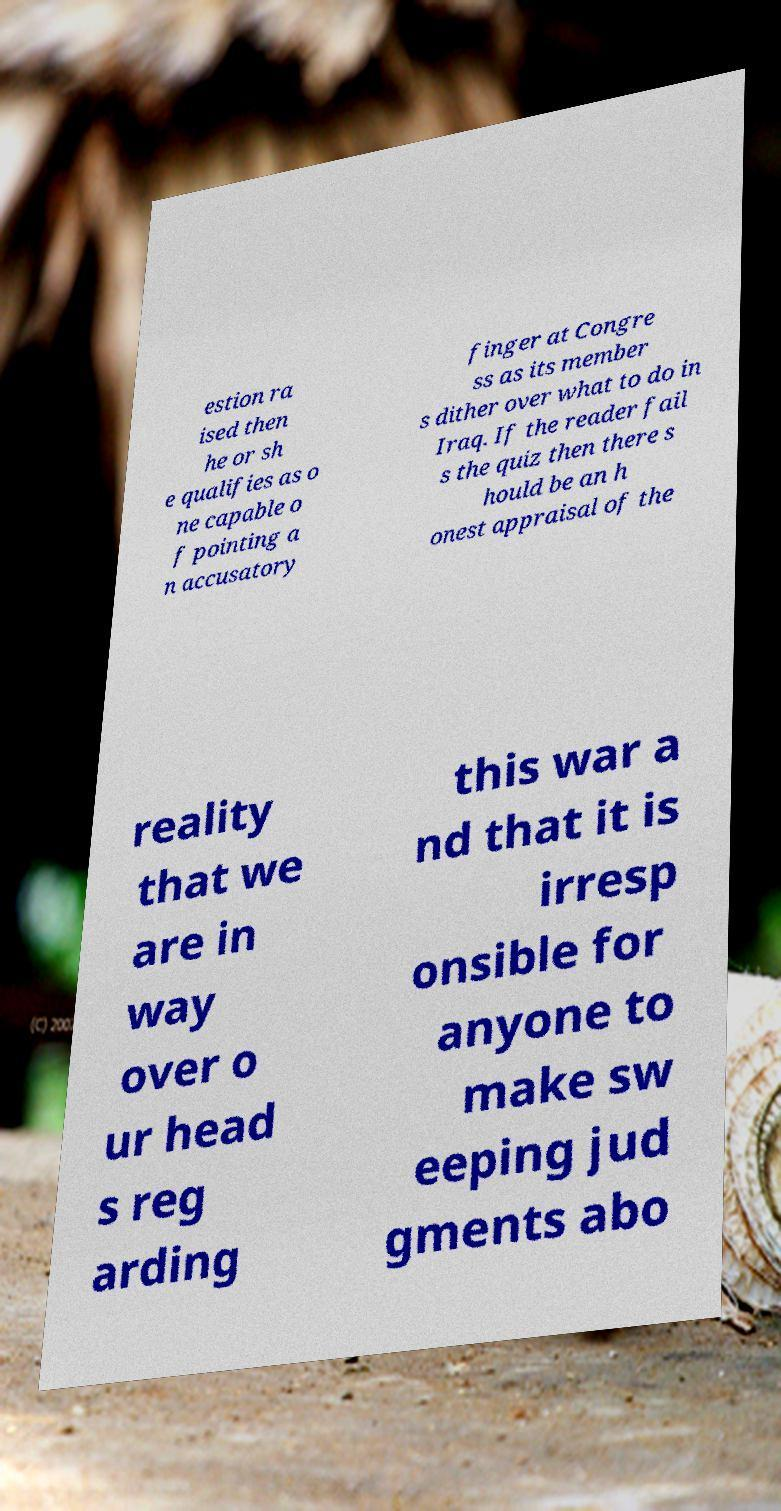Could you assist in decoding the text presented in this image and type it out clearly? estion ra ised then he or sh e qualifies as o ne capable o f pointing a n accusatory finger at Congre ss as its member s dither over what to do in Iraq. If the reader fail s the quiz then there s hould be an h onest appraisal of the reality that we are in way over o ur head s reg arding this war a nd that it is irresp onsible for anyone to make sw eeping jud gments abo 